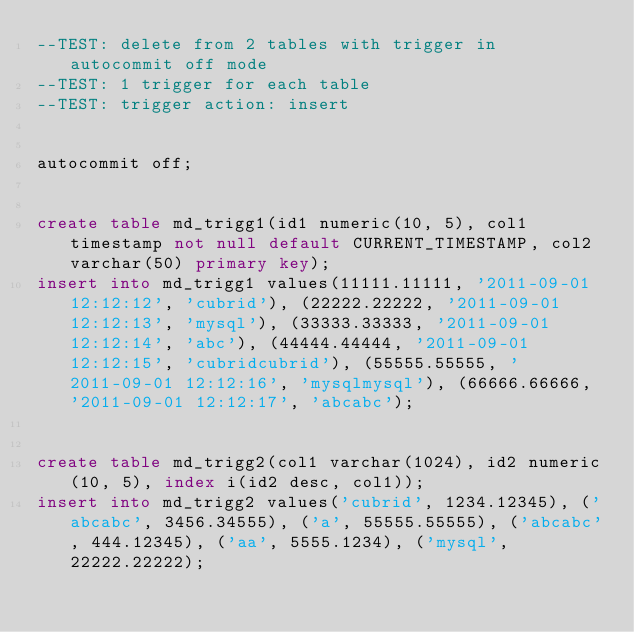Convert code to text. <code><loc_0><loc_0><loc_500><loc_500><_SQL_>--TEST: delete from 2 tables with trigger in autocommit off mode
--TEST: 1 trigger for each table
--TEST: trigger action: insert


autocommit off;


create table md_trigg1(id1 numeric(10, 5), col1 timestamp not null default CURRENT_TIMESTAMP, col2 varchar(50) primary key);
insert into md_trigg1 values(11111.11111, '2011-09-01 12:12:12', 'cubrid'), (22222.22222, '2011-09-01 12:12:13', 'mysql'), (33333.33333, '2011-09-01 12:12:14', 'abc'), (44444.44444, '2011-09-01 12:12:15', 'cubridcubrid'), (55555.55555, '2011-09-01 12:12:16', 'mysqlmysql'), (66666.66666, '2011-09-01 12:12:17', 'abcabc');


create table md_trigg2(col1 varchar(1024), id2 numeric(10, 5), index i(id2 desc, col1));
insert into md_trigg2 values('cubrid', 1234.12345), ('abcabc', 3456.34555), ('a', 55555.55555), ('abcabc', 444.12345), ('aa', 5555.1234), ('mysql', 22222.22222);</code> 